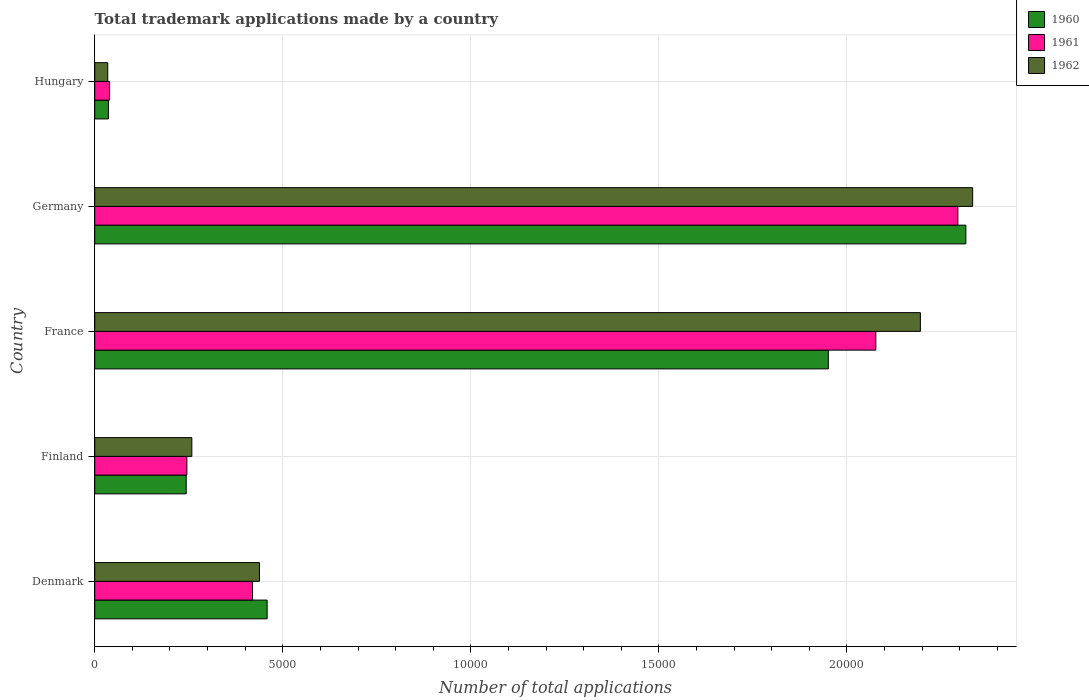How many bars are there on the 3rd tick from the bottom?
Provide a short and direct response. 3. What is the label of the 1st group of bars from the top?
Give a very brief answer. Hungary. In how many cases, is the number of bars for a given country not equal to the number of legend labels?
Your response must be concise. 0. What is the number of applications made by in 1962 in Finland?
Your response must be concise. 2582. Across all countries, what is the maximum number of applications made by in 1962?
Offer a very short reply. 2.33e+04. Across all countries, what is the minimum number of applications made by in 1961?
Your response must be concise. 396. In which country was the number of applications made by in 1960 minimum?
Your answer should be very brief. Hungary. What is the total number of applications made by in 1961 in the graph?
Offer a very short reply. 5.08e+04. What is the difference between the number of applications made by in 1961 in France and that in Hungary?
Offer a very short reply. 2.04e+04. What is the difference between the number of applications made by in 1961 in Finland and the number of applications made by in 1960 in France?
Keep it short and to the point. -1.71e+04. What is the average number of applications made by in 1961 per country?
Provide a succinct answer. 1.02e+04. What is the difference between the number of applications made by in 1960 and number of applications made by in 1962 in Denmark?
Provide a succinct answer. 204. What is the ratio of the number of applications made by in 1961 in France to that in Hungary?
Ensure brevity in your answer.  52.44. Is the number of applications made by in 1960 in Finland less than that in Hungary?
Give a very brief answer. No. What is the difference between the highest and the second highest number of applications made by in 1962?
Your answer should be compact. 1390. What is the difference between the highest and the lowest number of applications made by in 1960?
Make the answer very short. 2.28e+04. What does the 3rd bar from the bottom in Hungary represents?
Your response must be concise. 1962. Is it the case that in every country, the sum of the number of applications made by in 1960 and number of applications made by in 1962 is greater than the number of applications made by in 1961?
Make the answer very short. Yes. How many bars are there?
Make the answer very short. 15. Are all the bars in the graph horizontal?
Your response must be concise. Yes. How many countries are there in the graph?
Provide a succinct answer. 5. What is the difference between two consecutive major ticks on the X-axis?
Give a very brief answer. 5000. Does the graph contain any zero values?
Offer a terse response. No. Does the graph contain grids?
Your answer should be compact. Yes. How many legend labels are there?
Offer a terse response. 3. How are the legend labels stacked?
Ensure brevity in your answer.  Vertical. What is the title of the graph?
Provide a short and direct response. Total trademark applications made by a country. Does "1988" appear as one of the legend labels in the graph?
Provide a succinct answer. No. What is the label or title of the X-axis?
Give a very brief answer. Number of total applications. What is the Number of total applications of 1960 in Denmark?
Your answer should be very brief. 4584. What is the Number of total applications in 1961 in Denmark?
Your response must be concise. 4196. What is the Number of total applications of 1962 in Denmark?
Ensure brevity in your answer.  4380. What is the Number of total applications in 1960 in Finland?
Offer a very short reply. 2432. What is the Number of total applications in 1961 in Finland?
Your answer should be very brief. 2450. What is the Number of total applications of 1962 in Finland?
Give a very brief answer. 2582. What is the Number of total applications in 1960 in France?
Make the answer very short. 1.95e+04. What is the Number of total applications in 1961 in France?
Your response must be concise. 2.08e+04. What is the Number of total applications in 1962 in France?
Keep it short and to the point. 2.20e+04. What is the Number of total applications of 1960 in Germany?
Your answer should be compact. 2.32e+04. What is the Number of total applications of 1961 in Germany?
Keep it short and to the point. 2.29e+04. What is the Number of total applications in 1962 in Germany?
Give a very brief answer. 2.33e+04. What is the Number of total applications in 1960 in Hungary?
Provide a short and direct response. 363. What is the Number of total applications in 1961 in Hungary?
Give a very brief answer. 396. What is the Number of total applications in 1962 in Hungary?
Provide a short and direct response. 346. Across all countries, what is the maximum Number of total applications in 1960?
Give a very brief answer. 2.32e+04. Across all countries, what is the maximum Number of total applications of 1961?
Ensure brevity in your answer.  2.29e+04. Across all countries, what is the maximum Number of total applications in 1962?
Provide a short and direct response. 2.33e+04. Across all countries, what is the minimum Number of total applications of 1960?
Keep it short and to the point. 363. Across all countries, what is the minimum Number of total applications in 1961?
Ensure brevity in your answer.  396. Across all countries, what is the minimum Number of total applications in 1962?
Your answer should be compact. 346. What is the total Number of total applications in 1960 in the graph?
Make the answer very short. 5.00e+04. What is the total Number of total applications in 1961 in the graph?
Your response must be concise. 5.08e+04. What is the total Number of total applications in 1962 in the graph?
Offer a terse response. 5.26e+04. What is the difference between the Number of total applications of 1960 in Denmark and that in Finland?
Offer a terse response. 2152. What is the difference between the Number of total applications of 1961 in Denmark and that in Finland?
Make the answer very short. 1746. What is the difference between the Number of total applications in 1962 in Denmark and that in Finland?
Your answer should be very brief. 1798. What is the difference between the Number of total applications in 1960 in Denmark and that in France?
Give a very brief answer. -1.49e+04. What is the difference between the Number of total applications of 1961 in Denmark and that in France?
Give a very brief answer. -1.66e+04. What is the difference between the Number of total applications in 1962 in Denmark and that in France?
Provide a succinct answer. -1.76e+04. What is the difference between the Number of total applications in 1960 in Denmark and that in Germany?
Your answer should be compact. -1.86e+04. What is the difference between the Number of total applications in 1961 in Denmark and that in Germany?
Make the answer very short. -1.88e+04. What is the difference between the Number of total applications of 1962 in Denmark and that in Germany?
Your response must be concise. -1.90e+04. What is the difference between the Number of total applications of 1960 in Denmark and that in Hungary?
Provide a short and direct response. 4221. What is the difference between the Number of total applications in 1961 in Denmark and that in Hungary?
Offer a very short reply. 3800. What is the difference between the Number of total applications of 1962 in Denmark and that in Hungary?
Provide a succinct answer. 4034. What is the difference between the Number of total applications of 1960 in Finland and that in France?
Ensure brevity in your answer.  -1.71e+04. What is the difference between the Number of total applications of 1961 in Finland and that in France?
Provide a succinct answer. -1.83e+04. What is the difference between the Number of total applications of 1962 in Finland and that in France?
Your answer should be compact. -1.94e+04. What is the difference between the Number of total applications in 1960 in Finland and that in Germany?
Offer a very short reply. -2.07e+04. What is the difference between the Number of total applications of 1961 in Finland and that in Germany?
Ensure brevity in your answer.  -2.05e+04. What is the difference between the Number of total applications of 1962 in Finland and that in Germany?
Give a very brief answer. -2.08e+04. What is the difference between the Number of total applications in 1960 in Finland and that in Hungary?
Give a very brief answer. 2069. What is the difference between the Number of total applications in 1961 in Finland and that in Hungary?
Provide a short and direct response. 2054. What is the difference between the Number of total applications in 1962 in Finland and that in Hungary?
Make the answer very short. 2236. What is the difference between the Number of total applications in 1960 in France and that in Germany?
Offer a terse response. -3657. What is the difference between the Number of total applications in 1961 in France and that in Germany?
Offer a terse response. -2181. What is the difference between the Number of total applications of 1962 in France and that in Germany?
Your answer should be very brief. -1390. What is the difference between the Number of total applications of 1960 in France and that in Hungary?
Provide a succinct answer. 1.91e+04. What is the difference between the Number of total applications in 1961 in France and that in Hungary?
Ensure brevity in your answer.  2.04e+04. What is the difference between the Number of total applications in 1962 in France and that in Hungary?
Give a very brief answer. 2.16e+04. What is the difference between the Number of total applications of 1960 in Germany and that in Hungary?
Ensure brevity in your answer.  2.28e+04. What is the difference between the Number of total applications in 1961 in Germany and that in Hungary?
Your answer should be very brief. 2.26e+04. What is the difference between the Number of total applications in 1962 in Germany and that in Hungary?
Your answer should be compact. 2.30e+04. What is the difference between the Number of total applications in 1960 in Denmark and the Number of total applications in 1961 in Finland?
Ensure brevity in your answer.  2134. What is the difference between the Number of total applications of 1960 in Denmark and the Number of total applications of 1962 in Finland?
Give a very brief answer. 2002. What is the difference between the Number of total applications of 1961 in Denmark and the Number of total applications of 1962 in Finland?
Make the answer very short. 1614. What is the difference between the Number of total applications in 1960 in Denmark and the Number of total applications in 1961 in France?
Give a very brief answer. -1.62e+04. What is the difference between the Number of total applications of 1960 in Denmark and the Number of total applications of 1962 in France?
Provide a succinct answer. -1.74e+04. What is the difference between the Number of total applications in 1961 in Denmark and the Number of total applications in 1962 in France?
Your response must be concise. -1.78e+04. What is the difference between the Number of total applications in 1960 in Denmark and the Number of total applications in 1961 in Germany?
Ensure brevity in your answer.  -1.84e+04. What is the difference between the Number of total applications of 1960 in Denmark and the Number of total applications of 1962 in Germany?
Your answer should be very brief. -1.88e+04. What is the difference between the Number of total applications of 1961 in Denmark and the Number of total applications of 1962 in Germany?
Your answer should be very brief. -1.91e+04. What is the difference between the Number of total applications in 1960 in Denmark and the Number of total applications in 1961 in Hungary?
Your answer should be compact. 4188. What is the difference between the Number of total applications of 1960 in Denmark and the Number of total applications of 1962 in Hungary?
Your response must be concise. 4238. What is the difference between the Number of total applications in 1961 in Denmark and the Number of total applications in 1962 in Hungary?
Give a very brief answer. 3850. What is the difference between the Number of total applications of 1960 in Finland and the Number of total applications of 1961 in France?
Provide a succinct answer. -1.83e+04. What is the difference between the Number of total applications of 1960 in Finland and the Number of total applications of 1962 in France?
Provide a succinct answer. -1.95e+04. What is the difference between the Number of total applications of 1961 in Finland and the Number of total applications of 1962 in France?
Your answer should be compact. -1.95e+04. What is the difference between the Number of total applications of 1960 in Finland and the Number of total applications of 1961 in Germany?
Provide a short and direct response. -2.05e+04. What is the difference between the Number of total applications in 1960 in Finland and the Number of total applications in 1962 in Germany?
Offer a terse response. -2.09e+04. What is the difference between the Number of total applications of 1961 in Finland and the Number of total applications of 1962 in Germany?
Provide a succinct answer. -2.09e+04. What is the difference between the Number of total applications in 1960 in Finland and the Number of total applications in 1961 in Hungary?
Ensure brevity in your answer.  2036. What is the difference between the Number of total applications of 1960 in Finland and the Number of total applications of 1962 in Hungary?
Your answer should be very brief. 2086. What is the difference between the Number of total applications in 1961 in Finland and the Number of total applications in 1962 in Hungary?
Keep it short and to the point. 2104. What is the difference between the Number of total applications of 1960 in France and the Number of total applications of 1961 in Germany?
Your answer should be very brief. -3445. What is the difference between the Number of total applications in 1960 in France and the Number of total applications in 1962 in Germany?
Offer a terse response. -3838. What is the difference between the Number of total applications of 1961 in France and the Number of total applications of 1962 in Germany?
Provide a short and direct response. -2574. What is the difference between the Number of total applications in 1960 in France and the Number of total applications in 1961 in Hungary?
Your answer should be compact. 1.91e+04. What is the difference between the Number of total applications in 1960 in France and the Number of total applications in 1962 in Hungary?
Your answer should be very brief. 1.92e+04. What is the difference between the Number of total applications of 1961 in France and the Number of total applications of 1962 in Hungary?
Your answer should be very brief. 2.04e+04. What is the difference between the Number of total applications in 1960 in Germany and the Number of total applications in 1961 in Hungary?
Keep it short and to the point. 2.28e+04. What is the difference between the Number of total applications of 1960 in Germany and the Number of total applications of 1962 in Hungary?
Make the answer very short. 2.28e+04. What is the difference between the Number of total applications of 1961 in Germany and the Number of total applications of 1962 in Hungary?
Provide a succinct answer. 2.26e+04. What is the average Number of total applications of 1960 per country?
Ensure brevity in your answer.  1.00e+04. What is the average Number of total applications of 1961 per country?
Your answer should be very brief. 1.02e+04. What is the average Number of total applications in 1962 per country?
Your response must be concise. 1.05e+04. What is the difference between the Number of total applications in 1960 and Number of total applications in 1961 in Denmark?
Your answer should be compact. 388. What is the difference between the Number of total applications in 1960 and Number of total applications in 1962 in Denmark?
Give a very brief answer. 204. What is the difference between the Number of total applications of 1961 and Number of total applications of 1962 in Denmark?
Offer a very short reply. -184. What is the difference between the Number of total applications in 1960 and Number of total applications in 1962 in Finland?
Provide a succinct answer. -150. What is the difference between the Number of total applications in 1961 and Number of total applications in 1962 in Finland?
Make the answer very short. -132. What is the difference between the Number of total applications in 1960 and Number of total applications in 1961 in France?
Provide a short and direct response. -1264. What is the difference between the Number of total applications in 1960 and Number of total applications in 1962 in France?
Offer a very short reply. -2448. What is the difference between the Number of total applications of 1961 and Number of total applications of 1962 in France?
Keep it short and to the point. -1184. What is the difference between the Number of total applications in 1960 and Number of total applications in 1961 in Germany?
Provide a succinct answer. 212. What is the difference between the Number of total applications of 1960 and Number of total applications of 1962 in Germany?
Keep it short and to the point. -181. What is the difference between the Number of total applications in 1961 and Number of total applications in 1962 in Germany?
Your answer should be very brief. -393. What is the difference between the Number of total applications in 1960 and Number of total applications in 1961 in Hungary?
Keep it short and to the point. -33. What is the difference between the Number of total applications in 1960 and Number of total applications in 1962 in Hungary?
Make the answer very short. 17. What is the ratio of the Number of total applications in 1960 in Denmark to that in Finland?
Your response must be concise. 1.88. What is the ratio of the Number of total applications of 1961 in Denmark to that in Finland?
Give a very brief answer. 1.71. What is the ratio of the Number of total applications in 1962 in Denmark to that in Finland?
Provide a succinct answer. 1.7. What is the ratio of the Number of total applications of 1960 in Denmark to that in France?
Your response must be concise. 0.23. What is the ratio of the Number of total applications of 1961 in Denmark to that in France?
Your response must be concise. 0.2. What is the ratio of the Number of total applications in 1962 in Denmark to that in France?
Your response must be concise. 0.2. What is the ratio of the Number of total applications in 1960 in Denmark to that in Germany?
Your answer should be compact. 0.2. What is the ratio of the Number of total applications in 1961 in Denmark to that in Germany?
Provide a succinct answer. 0.18. What is the ratio of the Number of total applications of 1962 in Denmark to that in Germany?
Offer a terse response. 0.19. What is the ratio of the Number of total applications of 1960 in Denmark to that in Hungary?
Make the answer very short. 12.63. What is the ratio of the Number of total applications of 1961 in Denmark to that in Hungary?
Offer a very short reply. 10.6. What is the ratio of the Number of total applications of 1962 in Denmark to that in Hungary?
Your response must be concise. 12.66. What is the ratio of the Number of total applications in 1960 in Finland to that in France?
Provide a succinct answer. 0.12. What is the ratio of the Number of total applications of 1961 in Finland to that in France?
Provide a succinct answer. 0.12. What is the ratio of the Number of total applications in 1962 in Finland to that in France?
Provide a short and direct response. 0.12. What is the ratio of the Number of total applications of 1960 in Finland to that in Germany?
Provide a short and direct response. 0.1. What is the ratio of the Number of total applications of 1961 in Finland to that in Germany?
Provide a short and direct response. 0.11. What is the ratio of the Number of total applications of 1962 in Finland to that in Germany?
Ensure brevity in your answer.  0.11. What is the ratio of the Number of total applications of 1960 in Finland to that in Hungary?
Your answer should be very brief. 6.7. What is the ratio of the Number of total applications of 1961 in Finland to that in Hungary?
Keep it short and to the point. 6.19. What is the ratio of the Number of total applications of 1962 in Finland to that in Hungary?
Offer a terse response. 7.46. What is the ratio of the Number of total applications in 1960 in France to that in Germany?
Your response must be concise. 0.84. What is the ratio of the Number of total applications in 1961 in France to that in Germany?
Provide a succinct answer. 0.91. What is the ratio of the Number of total applications in 1962 in France to that in Germany?
Offer a terse response. 0.94. What is the ratio of the Number of total applications of 1960 in France to that in Hungary?
Your answer should be compact. 53.73. What is the ratio of the Number of total applications of 1961 in France to that in Hungary?
Give a very brief answer. 52.44. What is the ratio of the Number of total applications of 1962 in France to that in Hungary?
Give a very brief answer. 63.45. What is the ratio of the Number of total applications in 1960 in Germany to that in Hungary?
Your response must be concise. 63.8. What is the ratio of the Number of total applications in 1961 in Germany to that in Hungary?
Provide a succinct answer. 57.95. What is the ratio of the Number of total applications in 1962 in Germany to that in Hungary?
Ensure brevity in your answer.  67.46. What is the difference between the highest and the second highest Number of total applications in 1960?
Your response must be concise. 3657. What is the difference between the highest and the second highest Number of total applications in 1961?
Keep it short and to the point. 2181. What is the difference between the highest and the second highest Number of total applications in 1962?
Make the answer very short. 1390. What is the difference between the highest and the lowest Number of total applications of 1960?
Your answer should be compact. 2.28e+04. What is the difference between the highest and the lowest Number of total applications of 1961?
Provide a succinct answer. 2.26e+04. What is the difference between the highest and the lowest Number of total applications in 1962?
Your answer should be very brief. 2.30e+04. 